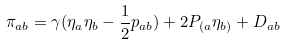<formula> <loc_0><loc_0><loc_500><loc_500>\pi _ { a b } = \gamma ( \eta _ { a } \eta _ { b } - \frac { 1 } { 2 } p _ { a b } ) + 2 P _ { ( a } \eta _ { b ) } + D _ { a b }</formula> 